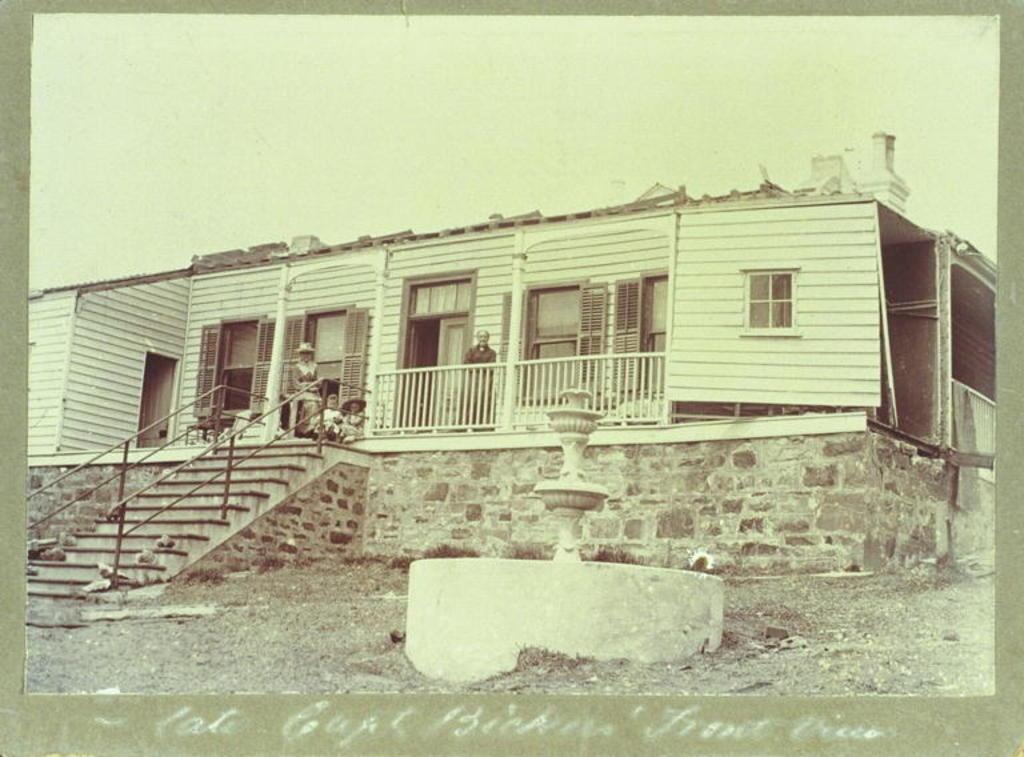How would you summarize this image in a sentence or two? In this image, this looks like a photo on a paper. I can see a house with the windows. There are few people standing and sitting. These are the stairs with the staircase holders. This is a sculptural fountain. At the bottom of the image, I can see the letters. 